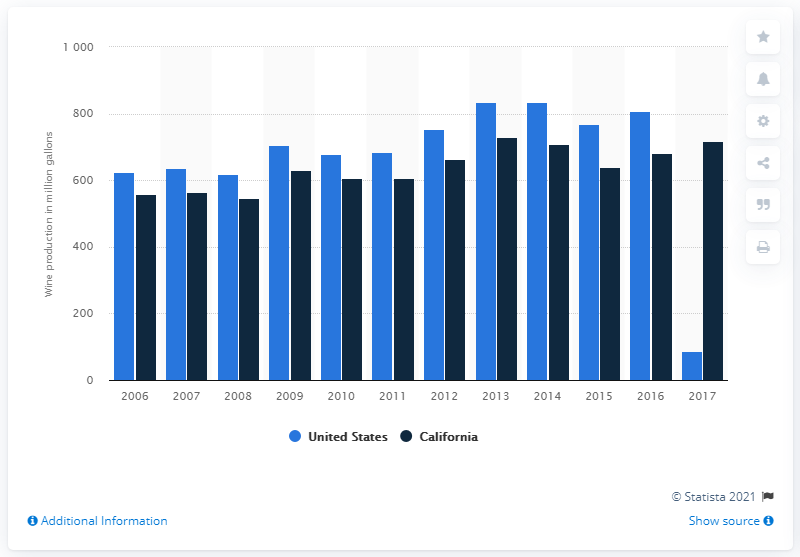List a handful of essential elements in this visual. According to the information given, California's wine production was highest in 2006. In 2016, the wine production in California was approximately 680.27 million gallons. 